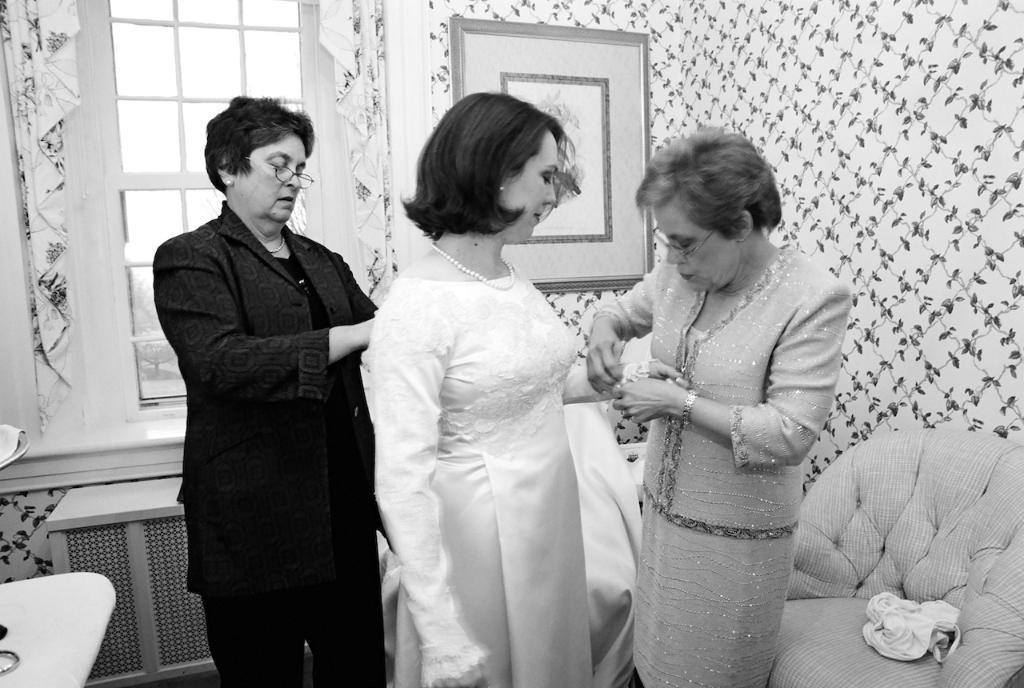Could you give a brief overview of what you see in this image? This is a black and white image. This picture is taken in the room. In this image, in the middle, we can see three people are standing. On the right side, we can see a couch, on the couch, we can see a cloth. In the left corner, we can see one edge of a table. On the table, we can see some objects. In the background, we can see some clothes, window, curtains and a photo frame which is attached to a wall. 